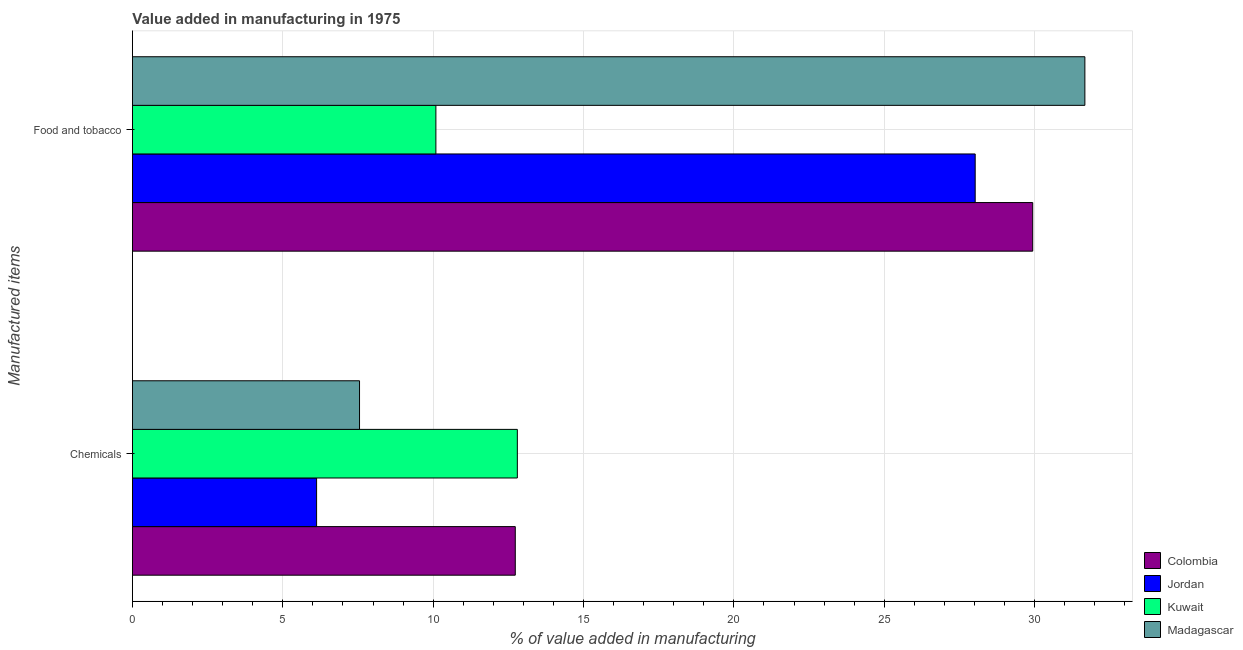How many different coloured bars are there?
Provide a succinct answer. 4. How many bars are there on the 1st tick from the bottom?
Ensure brevity in your answer.  4. What is the label of the 2nd group of bars from the top?
Your answer should be very brief. Chemicals. What is the value added by  manufacturing chemicals in Jordan?
Offer a very short reply. 6.12. Across all countries, what is the maximum value added by manufacturing food and tobacco?
Your response must be concise. 31.67. Across all countries, what is the minimum value added by  manufacturing chemicals?
Your response must be concise. 6.12. In which country was the value added by  manufacturing chemicals maximum?
Keep it short and to the point. Kuwait. In which country was the value added by manufacturing food and tobacco minimum?
Keep it short and to the point. Kuwait. What is the total value added by  manufacturing chemicals in the graph?
Provide a short and direct response. 39.2. What is the difference between the value added by  manufacturing chemicals in Jordan and that in Madagascar?
Your response must be concise. -1.43. What is the difference between the value added by  manufacturing chemicals in Colombia and the value added by manufacturing food and tobacco in Jordan?
Make the answer very short. -15.29. What is the average value added by  manufacturing chemicals per country?
Ensure brevity in your answer.  9.8. What is the difference between the value added by  manufacturing chemicals and value added by manufacturing food and tobacco in Kuwait?
Offer a very short reply. 2.71. In how many countries, is the value added by  manufacturing chemicals greater than 15 %?
Your response must be concise. 0. What is the ratio of the value added by manufacturing food and tobacco in Colombia to that in Kuwait?
Offer a very short reply. 2.97. In how many countries, is the value added by manufacturing food and tobacco greater than the average value added by manufacturing food and tobacco taken over all countries?
Your answer should be compact. 3. What does the 3rd bar from the top in Chemicals represents?
Give a very brief answer. Jordan. What does the 3rd bar from the bottom in Chemicals represents?
Make the answer very short. Kuwait. How many countries are there in the graph?
Your response must be concise. 4. Are the values on the major ticks of X-axis written in scientific E-notation?
Provide a succinct answer. No. Does the graph contain grids?
Provide a short and direct response. Yes. Where does the legend appear in the graph?
Your response must be concise. Bottom right. How are the legend labels stacked?
Make the answer very short. Vertical. What is the title of the graph?
Offer a very short reply. Value added in manufacturing in 1975. Does "Mongolia" appear as one of the legend labels in the graph?
Your answer should be very brief. No. What is the label or title of the X-axis?
Ensure brevity in your answer.  % of value added in manufacturing. What is the label or title of the Y-axis?
Your response must be concise. Manufactured items. What is the % of value added in manufacturing of Colombia in Chemicals?
Provide a succinct answer. 12.73. What is the % of value added in manufacturing in Jordan in Chemicals?
Offer a very short reply. 6.12. What is the % of value added in manufacturing in Kuwait in Chemicals?
Give a very brief answer. 12.8. What is the % of value added in manufacturing in Madagascar in Chemicals?
Your answer should be very brief. 7.55. What is the % of value added in manufacturing in Colombia in Food and tobacco?
Provide a succinct answer. 29.94. What is the % of value added in manufacturing in Jordan in Food and tobacco?
Provide a short and direct response. 28.02. What is the % of value added in manufacturing of Kuwait in Food and tobacco?
Provide a short and direct response. 10.09. What is the % of value added in manufacturing of Madagascar in Food and tobacco?
Your answer should be compact. 31.67. Across all Manufactured items, what is the maximum % of value added in manufacturing of Colombia?
Offer a terse response. 29.94. Across all Manufactured items, what is the maximum % of value added in manufacturing of Jordan?
Your response must be concise. 28.02. Across all Manufactured items, what is the maximum % of value added in manufacturing of Kuwait?
Offer a very short reply. 12.8. Across all Manufactured items, what is the maximum % of value added in manufacturing in Madagascar?
Keep it short and to the point. 31.67. Across all Manufactured items, what is the minimum % of value added in manufacturing of Colombia?
Give a very brief answer. 12.73. Across all Manufactured items, what is the minimum % of value added in manufacturing of Jordan?
Your answer should be very brief. 6.12. Across all Manufactured items, what is the minimum % of value added in manufacturing of Kuwait?
Your response must be concise. 10.09. Across all Manufactured items, what is the minimum % of value added in manufacturing of Madagascar?
Give a very brief answer. 7.55. What is the total % of value added in manufacturing in Colombia in the graph?
Your answer should be very brief. 42.67. What is the total % of value added in manufacturing of Jordan in the graph?
Give a very brief answer. 34.15. What is the total % of value added in manufacturing in Kuwait in the graph?
Your answer should be very brief. 22.89. What is the total % of value added in manufacturing in Madagascar in the graph?
Your answer should be very brief. 39.22. What is the difference between the % of value added in manufacturing in Colombia in Chemicals and that in Food and tobacco?
Your answer should be compact. -17.21. What is the difference between the % of value added in manufacturing of Jordan in Chemicals and that in Food and tobacco?
Ensure brevity in your answer.  -21.9. What is the difference between the % of value added in manufacturing of Kuwait in Chemicals and that in Food and tobacco?
Provide a short and direct response. 2.71. What is the difference between the % of value added in manufacturing in Madagascar in Chemicals and that in Food and tobacco?
Keep it short and to the point. -24.12. What is the difference between the % of value added in manufacturing in Colombia in Chemicals and the % of value added in manufacturing in Jordan in Food and tobacco?
Your answer should be very brief. -15.29. What is the difference between the % of value added in manufacturing in Colombia in Chemicals and the % of value added in manufacturing in Kuwait in Food and tobacco?
Your answer should be very brief. 2.64. What is the difference between the % of value added in manufacturing of Colombia in Chemicals and the % of value added in manufacturing of Madagascar in Food and tobacco?
Keep it short and to the point. -18.94. What is the difference between the % of value added in manufacturing in Jordan in Chemicals and the % of value added in manufacturing in Kuwait in Food and tobacco?
Your answer should be very brief. -3.97. What is the difference between the % of value added in manufacturing in Jordan in Chemicals and the % of value added in manufacturing in Madagascar in Food and tobacco?
Make the answer very short. -25.55. What is the difference between the % of value added in manufacturing in Kuwait in Chemicals and the % of value added in manufacturing in Madagascar in Food and tobacco?
Offer a very short reply. -18.87. What is the average % of value added in manufacturing in Colombia per Manufactured items?
Make the answer very short. 21.33. What is the average % of value added in manufacturing in Jordan per Manufactured items?
Your response must be concise. 17.07. What is the average % of value added in manufacturing of Kuwait per Manufactured items?
Your answer should be compact. 11.44. What is the average % of value added in manufacturing in Madagascar per Manufactured items?
Ensure brevity in your answer.  19.61. What is the difference between the % of value added in manufacturing of Colombia and % of value added in manufacturing of Jordan in Chemicals?
Your answer should be very brief. 6.61. What is the difference between the % of value added in manufacturing in Colombia and % of value added in manufacturing in Kuwait in Chemicals?
Provide a succinct answer. -0.07. What is the difference between the % of value added in manufacturing in Colombia and % of value added in manufacturing in Madagascar in Chemicals?
Ensure brevity in your answer.  5.18. What is the difference between the % of value added in manufacturing of Jordan and % of value added in manufacturing of Kuwait in Chemicals?
Your response must be concise. -6.68. What is the difference between the % of value added in manufacturing in Jordan and % of value added in manufacturing in Madagascar in Chemicals?
Ensure brevity in your answer.  -1.43. What is the difference between the % of value added in manufacturing of Kuwait and % of value added in manufacturing of Madagascar in Chemicals?
Offer a very short reply. 5.25. What is the difference between the % of value added in manufacturing in Colombia and % of value added in manufacturing in Jordan in Food and tobacco?
Keep it short and to the point. 1.91. What is the difference between the % of value added in manufacturing of Colombia and % of value added in manufacturing of Kuwait in Food and tobacco?
Offer a terse response. 19.85. What is the difference between the % of value added in manufacturing in Colombia and % of value added in manufacturing in Madagascar in Food and tobacco?
Your answer should be compact. -1.73. What is the difference between the % of value added in manufacturing of Jordan and % of value added in manufacturing of Kuwait in Food and tobacco?
Offer a terse response. 17.93. What is the difference between the % of value added in manufacturing in Jordan and % of value added in manufacturing in Madagascar in Food and tobacco?
Keep it short and to the point. -3.65. What is the difference between the % of value added in manufacturing in Kuwait and % of value added in manufacturing in Madagascar in Food and tobacco?
Ensure brevity in your answer.  -21.58. What is the ratio of the % of value added in manufacturing in Colombia in Chemicals to that in Food and tobacco?
Your response must be concise. 0.43. What is the ratio of the % of value added in manufacturing in Jordan in Chemicals to that in Food and tobacco?
Provide a short and direct response. 0.22. What is the ratio of the % of value added in manufacturing in Kuwait in Chemicals to that in Food and tobacco?
Your response must be concise. 1.27. What is the ratio of the % of value added in manufacturing of Madagascar in Chemicals to that in Food and tobacco?
Give a very brief answer. 0.24. What is the difference between the highest and the second highest % of value added in manufacturing in Colombia?
Make the answer very short. 17.21. What is the difference between the highest and the second highest % of value added in manufacturing in Jordan?
Make the answer very short. 21.9. What is the difference between the highest and the second highest % of value added in manufacturing of Kuwait?
Your answer should be very brief. 2.71. What is the difference between the highest and the second highest % of value added in manufacturing of Madagascar?
Make the answer very short. 24.12. What is the difference between the highest and the lowest % of value added in manufacturing in Colombia?
Make the answer very short. 17.21. What is the difference between the highest and the lowest % of value added in manufacturing of Jordan?
Offer a terse response. 21.9. What is the difference between the highest and the lowest % of value added in manufacturing in Kuwait?
Provide a short and direct response. 2.71. What is the difference between the highest and the lowest % of value added in manufacturing in Madagascar?
Ensure brevity in your answer.  24.12. 